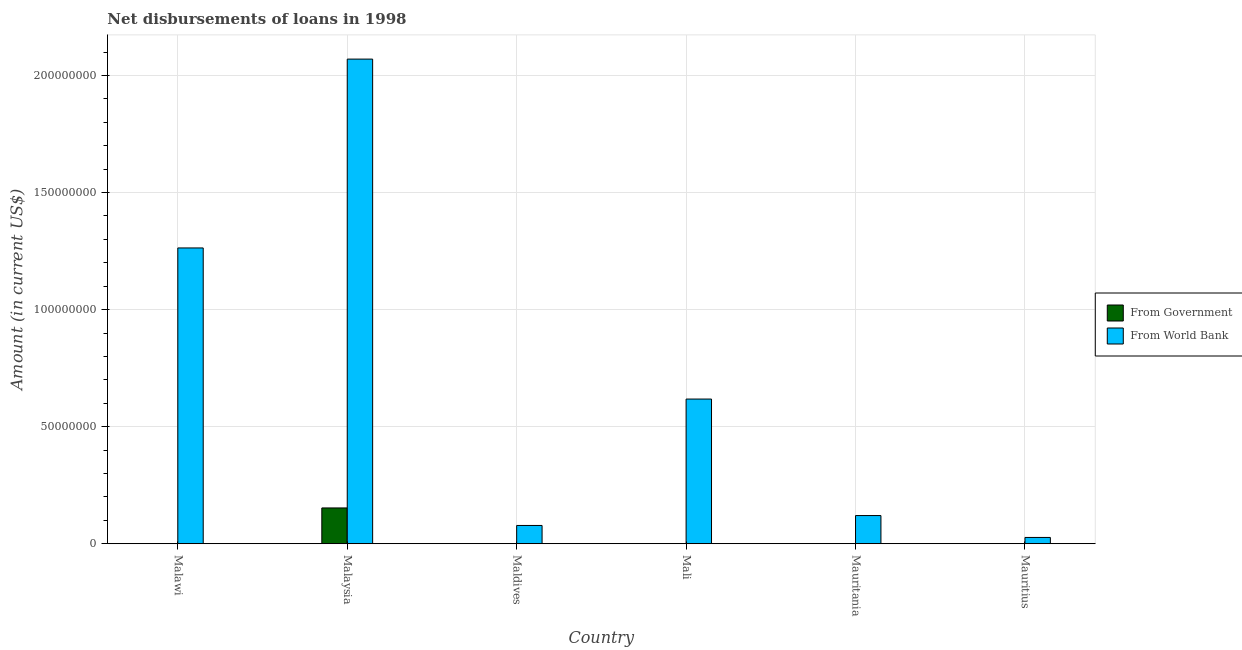How many different coloured bars are there?
Your answer should be very brief. 2. Are the number of bars per tick equal to the number of legend labels?
Give a very brief answer. No. What is the label of the 3rd group of bars from the left?
Give a very brief answer. Maldives. In how many cases, is the number of bars for a given country not equal to the number of legend labels?
Offer a very short reply. 5. What is the net disbursements of loan from government in Malaysia?
Provide a short and direct response. 1.53e+07. Across all countries, what is the maximum net disbursements of loan from world bank?
Your answer should be compact. 2.07e+08. In which country was the net disbursements of loan from world bank maximum?
Ensure brevity in your answer.  Malaysia. What is the total net disbursements of loan from world bank in the graph?
Provide a short and direct response. 4.18e+08. What is the difference between the net disbursements of loan from world bank in Maldives and that in Mali?
Provide a short and direct response. -5.40e+07. What is the difference between the net disbursements of loan from government in Malaysia and the net disbursements of loan from world bank in Maldives?
Give a very brief answer. 7.48e+06. What is the average net disbursements of loan from world bank per country?
Ensure brevity in your answer.  6.96e+07. What is the difference between the net disbursements of loan from world bank and net disbursements of loan from government in Malaysia?
Keep it short and to the point. 1.92e+08. In how many countries, is the net disbursements of loan from world bank greater than 160000000 US$?
Your response must be concise. 1. What is the ratio of the net disbursements of loan from world bank in Malawi to that in Maldives?
Your answer should be very brief. 16.18. What is the difference between the highest and the second highest net disbursements of loan from world bank?
Your response must be concise. 8.07e+07. What is the difference between the highest and the lowest net disbursements of loan from government?
Ensure brevity in your answer.  1.53e+07. How many bars are there?
Offer a very short reply. 7. Are all the bars in the graph horizontal?
Make the answer very short. No. Does the graph contain any zero values?
Offer a terse response. Yes. Does the graph contain grids?
Give a very brief answer. Yes. How many legend labels are there?
Ensure brevity in your answer.  2. What is the title of the graph?
Offer a very short reply. Net disbursements of loans in 1998. What is the label or title of the X-axis?
Your answer should be compact. Country. What is the Amount (in current US$) in From Government in Malawi?
Your answer should be very brief. 0. What is the Amount (in current US$) of From World Bank in Malawi?
Give a very brief answer. 1.26e+08. What is the Amount (in current US$) of From Government in Malaysia?
Provide a succinct answer. 1.53e+07. What is the Amount (in current US$) of From World Bank in Malaysia?
Give a very brief answer. 2.07e+08. What is the Amount (in current US$) of From World Bank in Maldives?
Provide a short and direct response. 7.81e+06. What is the Amount (in current US$) of From World Bank in Mali?
Ensure brevity in your answer.  6.18e+07. What is the Amount (in current US$) in From Government in Mauritania?
Your response must be concise. 0. What is the Amount (in current US$) of From World Bank in Mauritania?
Provide a succinct answer. 1.20e+07. What is the Amount (in current US$) in From Government in Mauritius?
Your response must be concise. 0. What is the Amount (in current US$) of From World Bank in Mauritius?
Make the answer very short. 2.69e+06. Across all countries, what is the maximum Amount (in current US$) in From Government?
Make the answer very short. 1.53e+07. Across all countries, what is the maximum Amount (in current US$) of From World Bank?
Provide a succinct answer. 2.07e+08. Across all countries, what is the minimum Amount (in current US$) in From Government?
Offer a very short reply. 0. Across all countries, what is the minimum Amount (in current US$) in From World Bank?
Your response must be concise. 2.69e+06. What is the total Amount (in current US$) in From Government in the graph?
Provide a short and direct response. 1.53e+07. What is the total Amount (in current US$) in From World Bank in the graph?
Your answer should be very brief. 4.18e+08. What is the difference between the Amount (in current US$) in From World Bank in Malawi and that in Malaysia?
Ensure brevity in your answer.  -8.07e+07. What is the difference between the Amount (in current US$) in From World Bank in Malawi and that in Maldives?
Your answer should be compact. 1.19e+08. What is the difference between the Amount (in current US$) in From World Bank in Malawi and that in Mali?
Keep it short and to the point. 6.45e+07. What is the difference between the Amount (in current US$) in From World Bank in Malawi and that in Mauritania?
Make the answer very short. 1.14e+08. What is the difference between the Amount (in current US$) of From World Bank in Malawi and that in Mauritius?
Your response must be concise. 1.24e+08. What is the difference between the Amount (in current US$) in From World Bank in Malaysia and that in Maldives?
Ensure brevity in your answer.  1.99e+08. What is the difference between the Amount (in current US$) in From World Bank in Malaysia and that in Mali?
Provide a succinct answer. 1.45e+08. What is the difference between the Amount (in current US$) of From World Bank in Malaysia and that in Mauritania?
Offer a terse response. 1.95e+08. What is the difference between the Amount (in current US$) in From World Bank in Malaysia and that in Mauritius?
Ensure brevity in your answer.  2.04e+08. What is the difference between the Amount (in current US$) in From World Bank in Maldives and that in Mali?
Your answer should be very brief. -5.40e+07. What is the difference between the Amount (in current US$) in From World Bank in Maldives and that in Mauritania?
Offer a very short reply. -4.23e+06. What is the difference between the Amount (in current US$) in From World Bank in Maldives and that in Mauritius?
Give a very brief answer. 5.12e+06. What is the difference between the Amount (in current US$) of From World Bank in Mali and that in Mauritania?
Make the answer very short. 4.98e+07. What is the difference between the Amount (in current US$) in From World Bank in Mali and that in Mauritius?
Provide a short and direct response. 5.91e+07. What is the difference between the Amount (in current US$) in From World Bank in Mauritania and that in Mauritius?
Your answer should be very brief. 9.35e+06. What is the difference between the Amount (in current US$) of From Government in Malaysia and the Amount (in current US$) of From World Bank in Maldives?
Your response must be concise. 7.48e+06. What is the difference between the Amount (in current US$) in From Government in Malaysia and the Amount (in current US$) in From World Bank in Mali?
Provide a short and direct response. -4.65e+07. What is the difference between the Amount (in current US$) of From Government in Malaysia and the Amount (in current US$) of From World Bank in Mauritania?
Keep it short and to the point. 3.25e+06. What is the difference between the Amount (in current US$) in From Government in Malaysia and the Amount (in current US$) in From World Bank in Mauritius?
Keep it short and to the point. 1.26e+07. What is the average Amount (in current US$) in From Government per country?
Provide a succinct answer. 2.55e+06. What is the average Amount (in current US$) in From World Bank per country?
Provide a succinct answer. 6.96e+07. What is the difference between the Amount (in current US$) of From Government and Amount (in current US$) of From World Bank in Malaysia?
Give a very brief answer. -1.92e+08. What is the ratio of the Amount (in current US$) in From World Bank in Malawi to that in Malaysia?
Give a very brief answer. 0.61. What is the ratio of the Amount (in current US$) in From World Bank in Malawi to that in Maldives?
Keep it short and to the point. 16.18. What is the ratio of the Amount (in current US$) of From World Bank in Malawi to that in Mali?
Provide a succinct answer. 2.04. What is the ratio of the Amount (in current US$) in From World Bank in Malawi to that in Mauritania?
Offer a terse response. 10.49. What is the ratio of the Amount (in current US$) of From World Bank in Malawi to that in Mauritius?
Offer a very short reply. 46.96. What is the ratio of the Amount (in current US$) in From World Bank in Malaysia to that in Maldives?
Offer a very short reply. 26.5. What is the ratio of the Amount (in current US$) of From World Bank in Malaysia to that in Mali?
Give a very brief answer. 3.35. What is the ratio of the Amount (in current US$) in From World Bank in Malaysia to that in Mauritania?
Your response must be concise. 17.19. What is the ratio of the Amount (in current US$) in From World Bank in Malaysia to that in Mauritius?
Provide a short and direct response. 76.95. What is the ratio of the Amount (in current US$) of From World Bank in Maldives to that in Mali?
Provide a short and direct response. 0.13. What is the ratio of the Amount (in current US$) in From World Bank in Maldives to that in Mauritania?
Your answer should be very brief. 0.65. What is the ratio of the Amount (in current US$) in From World Bank in Maldives to that in Mauritius?
Offer a very short reply. 2.9. What is the ratio of the Amount (in current US$) of From World Bank in Mali to that in Mauritania?
Your response must be concise. 5.13. What is the ratio of the Amount (in current US$) in From World Bank in Mali to that in Mauritius?
Make the answer very short. 22.97. What is the ratio of the Amount (in current US$) of From World Bank in Mauritania to that in Mauritius?
Your response must be concise. 4.48. What is the difference between the highest and the second highest Amount (in current US$) of From World Bank?
Ensure brevity in your answer.  8.07e+07. What is the difference between the highest and the lowest Amount (in current US$) of From Government?
Provide a short and direct response. 1.53e+07. What is the difference between the highest and the lowest Amount (in current US$) of From World Bank?
Keep it short and to the point. 2.04e+08. 